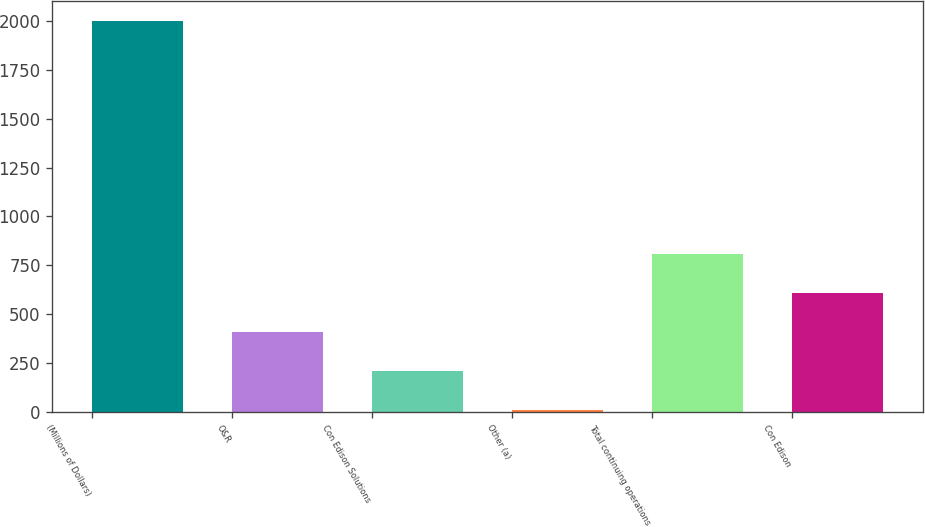<chart> <loc_0><loc_0><loc_500><loc_500><bar_chart><fcel>(Millions of Dollars)<fcel>O&R<fcel>Con Edison Solutions<fcel>Other (a)<fcel>Total continuing operations<fcel>Con Edison<nl><fcel>2003<fcel>408.6<fcel>209.3<fcel>10<fcel>807.2<fcel>607.9<nl></chart> 